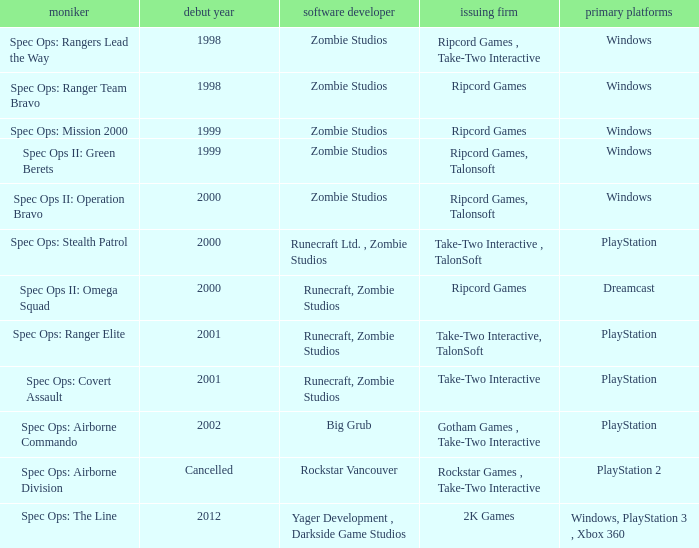Give me the full table as a dictionary. {'header': ['moniker', 'debut year', 'software developer', 'issuing firm', 'primary platforms'], 'rows': [['Spec Ops: Rangers Lead the Way', '1998', 'Zombie Studios', 'Ripcord Games , Take-Two Interactive', 'Windows'], ['Spec Ops: Ranger Team Bravo', '1998', 'Zombie Studios', 'Ripcord Games', 'Windows'], ['Spec Ops: Mission 2000', '1999', 'Zombie Studios', 'Ripcord Games', 'Windows'], ['Spec Ops II: Green Berets', '1999', 'Zombie Studios', 'Ripcord Games, Talonsoft', 'Windows'], ['Spec Ops II: Operation Bravo', '2000', 'Zombie Studios', 'Ripcord Games, Talonsoft', 'Windows'], ['Spec Ops: Stealth Patrol', '2000', 'Runecraft Ltd. , Zombie Studios', 'Take-Two Interactive , TalonSoft', 'PlayStation'], ['Spec Ops II: Omega Squad', '2000', 'Runecraft, Zombie Studios', 'Ripcord Games', 'Dreamcast'], ['Spec Ops: Ranger Elite', '2001', 'Runecraft, Zombie Studios', 'Take-Two Interactive, TalonSoft', 'PlayStation'], ['Spec Ops: Covert Assault', '2001', 'Runecraft, Zombie Studios', 'Take-Two Interactive', 'PlayStation'], ['Spec Ops: Airborne Commando', '2002', 'Big Grub', 'Gotham Games , Take-Two Interactive', 'PlayStation'], ['Spec Ops: Airborne Division', 'Cancelled', 'Rockstar Vancouver', 'Rockstar Games , Take-Two Interactive', 'PlayStation 2'], ['Spec Ops: The Line', '2012', 'Yager Development , Darkside Game Studios', '2K Games', 'Windows, PlayStation 3 , Xbox 360']]} Which publisher has release year of 2000 and an original dreamcast platform? Ripcord Games. 